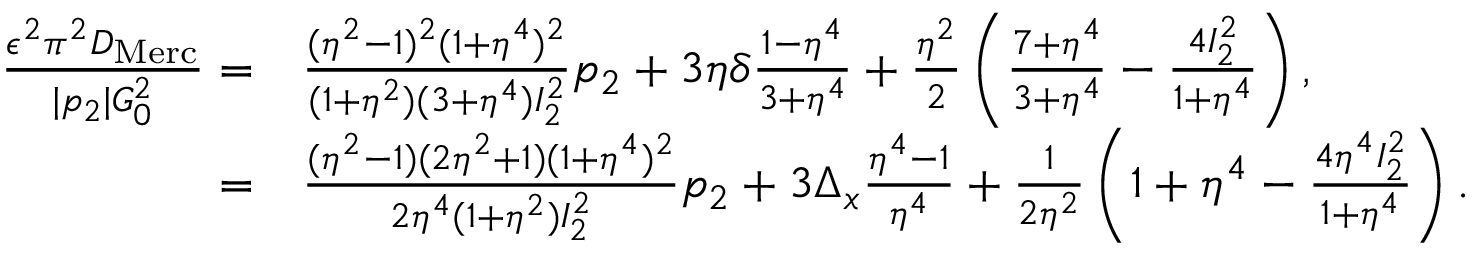<formula> <loc_0><loc_0><loc_500><loc_500>\begin{array} { r l } { \frac { \epsilon ^ { 2 } \pi ^ { 2 } D _ { M e r c } } { | p _ { 2 } | G _ { 0 } ^ { 2 } } = } & \frac { ( \eta ^ { 2 } - 1 ) ^ { 2 } ( 1 + \eta ^ { 4 } ) ^ { 2 } } { ( 1 + \eta ^ { 2 } ) ( 3 + \eta ^ { 4 } ) I _ { 2 } ^ { 2 } } p _ { 2 } + 3 \eta \delta \frac { 1 - \eta ^ { 4 } } { 3 + \eta ^ { 4 } } + \frac { \eta ^ { 2 } } { 2 } \left ( \frac { 7 + \eta ^ { 4 } } { 3 + \eta ^ { 4 } } - \frac { 4 I _ { 2 } ^ { 2 } } { 1 + \eta ^ { 4 } } \right ) , } \\ { = } & \frac { ( \eta ^ { 2 } - 1 ) ( 2 \eta ^ { 2 } + 1 ) ( 1 + \eta ^ { 4 } ) ^ { 2 } } { 2 \eta ^ { 4 } ( 1 + \eta ^ { 2 } ) I _ { 2 } ^ { 2 } } p _ { 2 } + 3 \Delta _ { x } \frac { \eta ^ { 4 } - 1 } { \eta ^ { 4 } } + \frac { 1 } { 2 \eta ^ { 2 } } \left ( 1 + \eta ^ { 4 } - \frac { 4 \eta ^ { 4 } I _ { 2 } ^ { 2 } } { 1 + \eta ^ { 4 } } \right ) . } \end{array}</formula> 